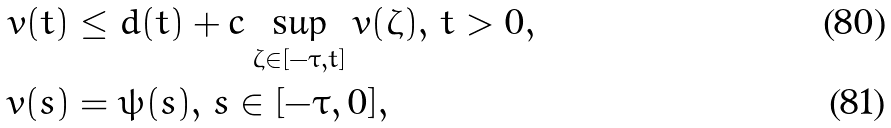<formula> <loc_0><loc_0><loc_500><loc_500>v ( t ) & \leq d ( t ) + c \sup _ { \zeta \in [ - \tau , t ] } v ( \zeta ) , \, t > 0 , \\ v ( s ) & = \psi ( s ) , \, s \in [ - \tau , 0 ] ,</formula> 